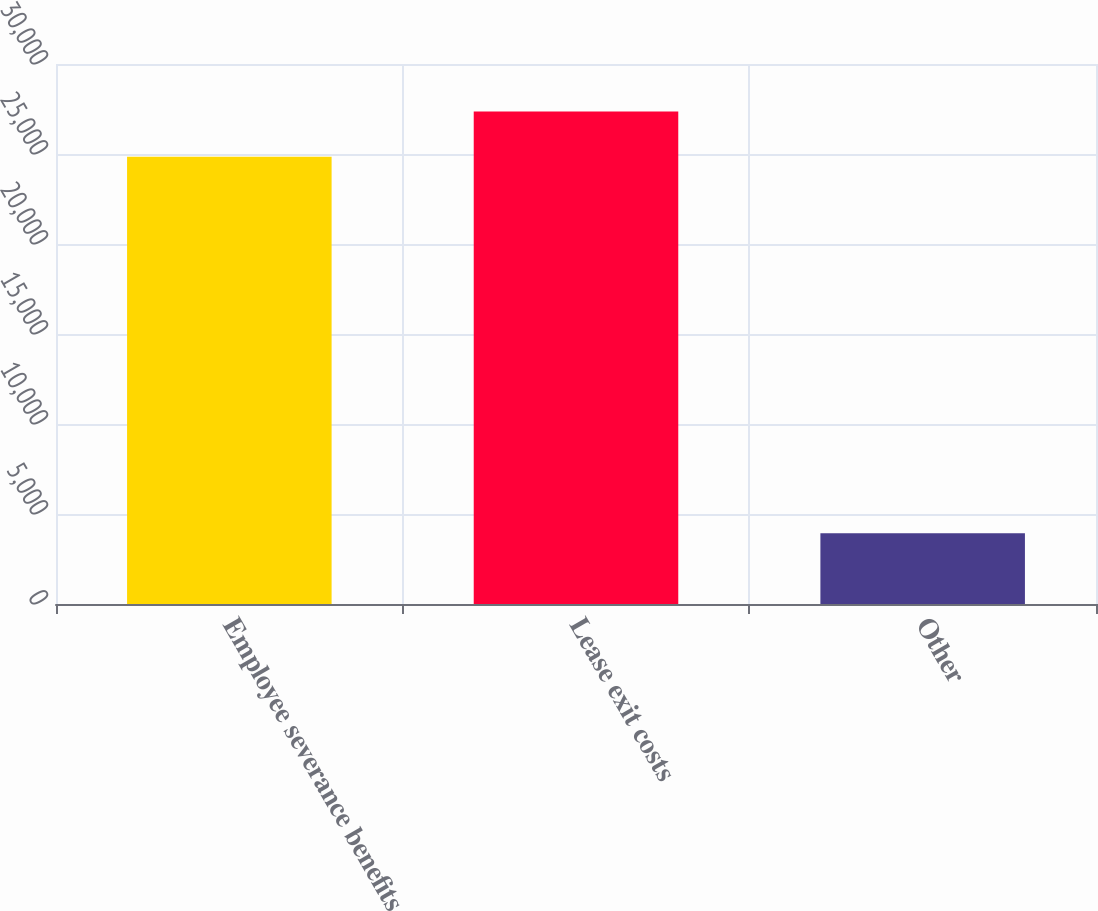<chart> <loc_0><loc_0><loc_500><loc_500><bar_chart><fcel>Employee severance benefits<fcel>Lease exit costs<fcel>Other<nl><fcel>24850<fcel>27356<fcel>3929<nl></chart> 